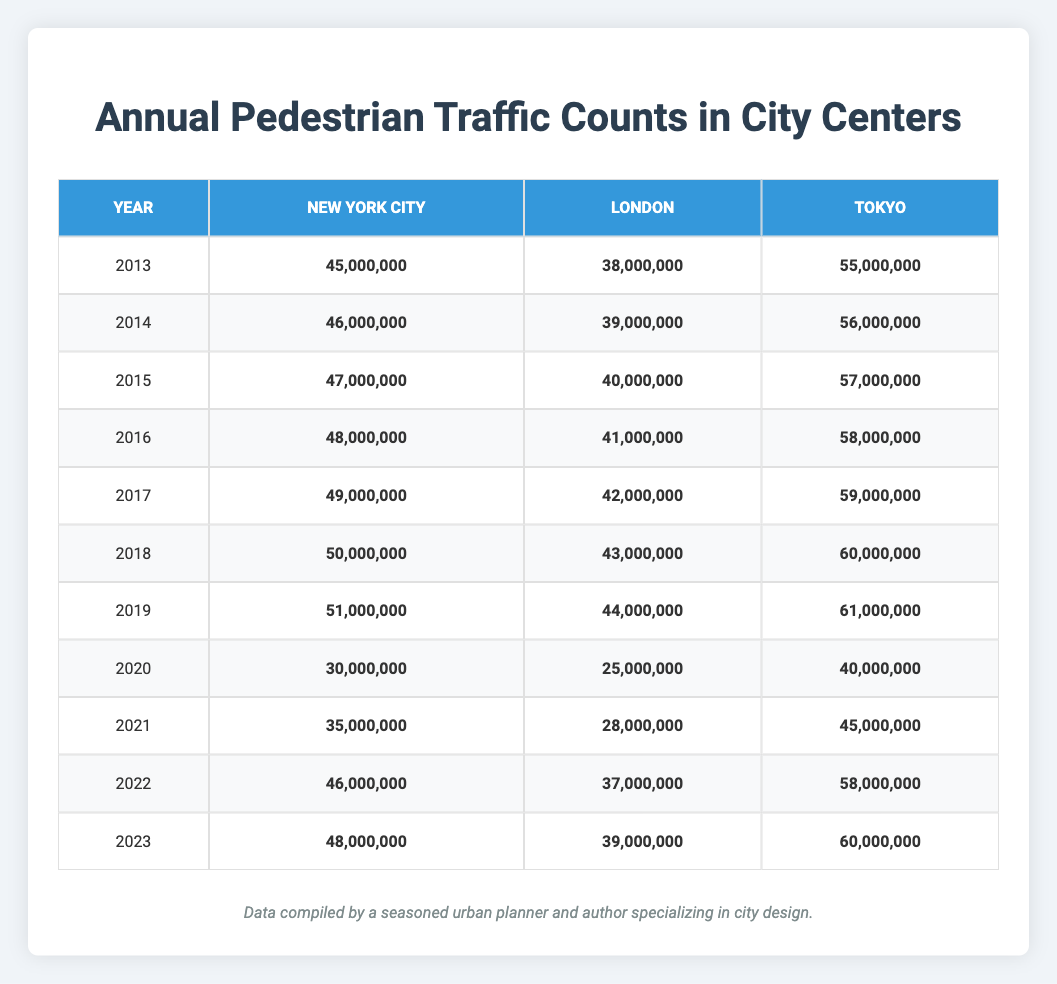What was the pedestrian traffic count in London in 2020? The table shows that London had a pedestrian traffic count of 25,000,000 in 2020.
Answer: 25,000,000 What was the significant change in pedestrian traffic from 2019 to 2020 for New York City? In 2019, New York City had a count of 51,000,000, which dropped to 30,000,000 in 2020. The change is 51,000,000 - 30,000,000 = 21,000,000, indicating a significant decrease.
Answer: 21,000,000 Did Tokyo's pedestrian traffic count in 2023 exceed its count in 2018? The table shows that Tokyo had a count of 60,000,000 in 2023 and 60,000,000 in 2018, so it did not exceed.
Answer: No What was the average annual pedestrian traffic count for London over the years 2013 to 2023? The total counts for London from 2013 to 2023 are: 38,000,000 + 39,000,000 + 40,000,000 + 41,000,000 + 42,000,000 + 43,000,000 + 44,000,000 + 25,000,000 + 28,000,000 + 37,000,000 + 39,000,000 =  426,000,000. There are 11 data points, so the average is 426,000,000 / 11 = 38,727,273 (rounded).
Answer: 38,727,273 Was the pedestrian traffic count in any city in 2021 higher than in the previous year? For New York City, the count increased from 30,000,000 in 2020 to 35,000,000 in 2021. London increased from 25,000,000 to 28,000,000. Tokyo also increased from 40,000,000 to 45,000,000. Therefore, yes, all cities had higher counts in 2021 compared to 2020.
Answer: Yes What was the percentage increase in pedestrian traffic counts for Tokyo from 2021 to 2022? Tokyo's count went from 45,000,000 in 2021 to 58,000,000 in 2022. The increase is 58,000,000 - 45,000,000 = 13,000,000. The percentage increase is (13,000,000 / 45,000,000) * 100 = 28.89%.
Answer: 28.89% Which city had the highest pedestrian traffic count in 2015? The table lists the pedestrian counts for 2015 as follows: New York City had 47,000,000, London had 40,000,000, and Tokyo had 57,000,000. Thus, Tokyo had the highest count.
Answer: Tokyo How did the pedestrian traffic in New York City change from 2013 to 2023 in absolute terms? In 2013, New York City's count was 45,000,000, and in 2023 it was 48,000,000. The absolute change is 48,000,000 - 45,000,000 = 3,000,000.
Answer: 3,000,000 